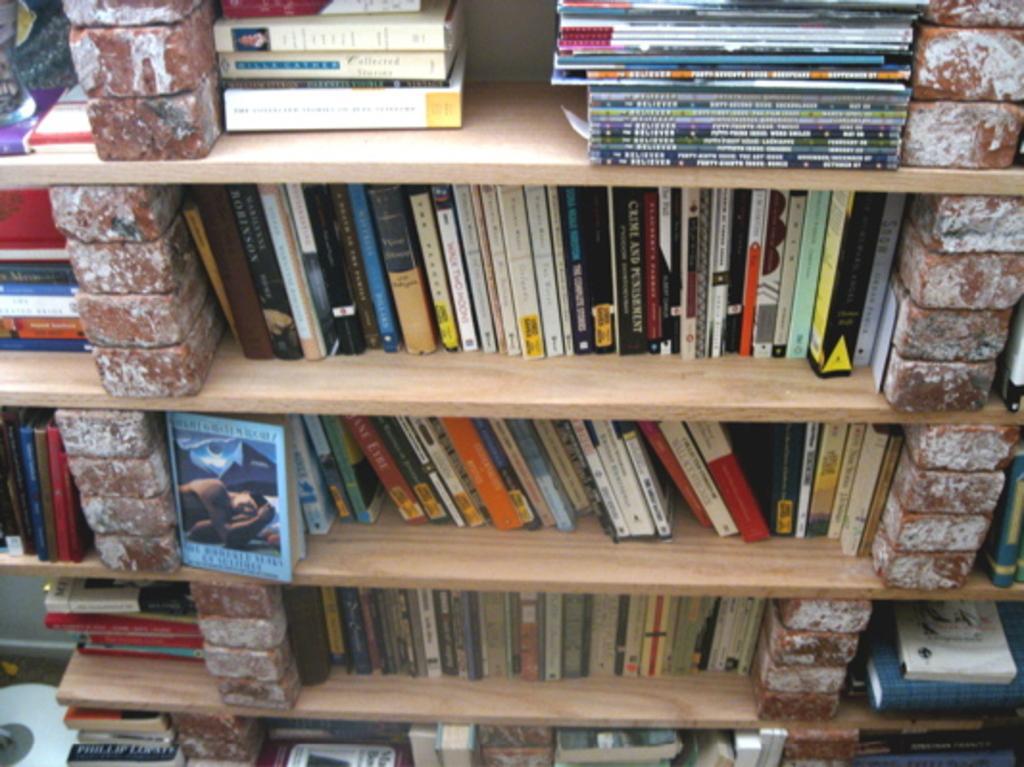Describe this image in one or two sentences. In the image there are wooden surfaces with books on it. And also there are cracks on wooden surface. 